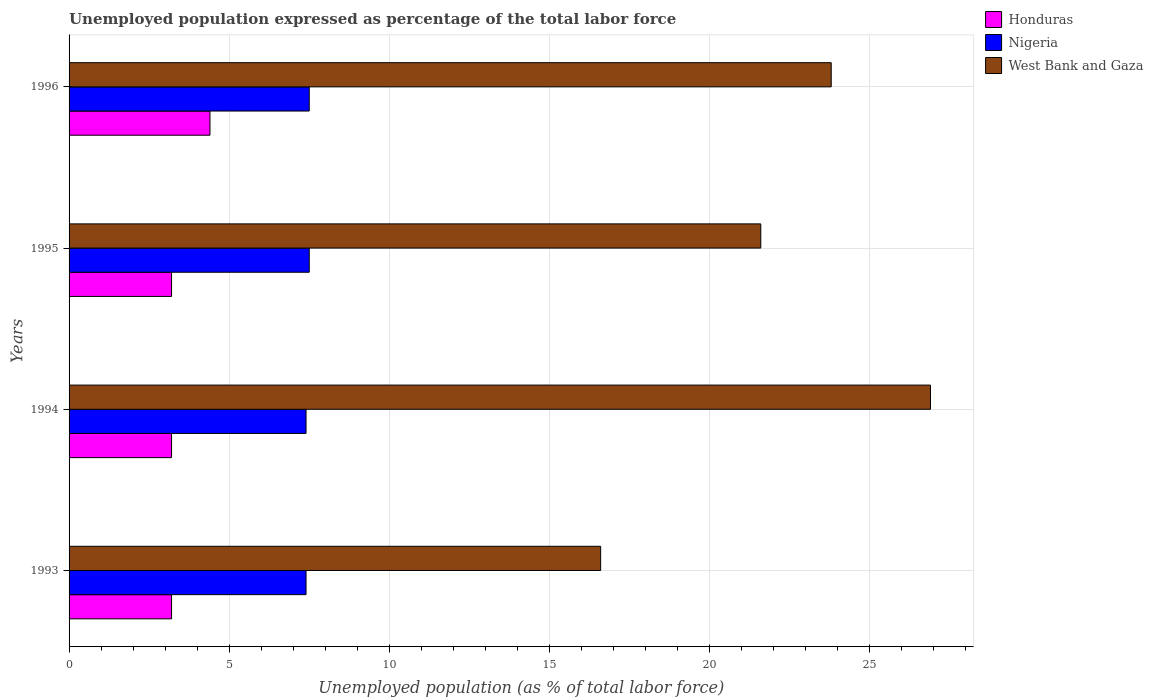How many different coloured bars are there?
Offer a terse response. 3. How many groups of bars are there?
Make the answer very short. 4. Are the number of bars per tick equal to the number of legend labels?
Ensure brevity in your answer.  Yes. Are the number of bars on each tick of the Y-axis equal?
Offer a very short reply. Yes. How many bars are there on the 2nd tick from the top?
Give a very brief answer. 3. In how many cases, is the number of bars for a given year not equal to the number of legend labels?
Your response must be concise. 0. What is the unemployment in in West Bank and Gaza in 1994?
Your answer should be very brief. 26.9. Across all years, what is the maximum unemployment in in West Bank and Gaza?
Keep it short and to the point. 26.9. Across all years, what is the minimum unemployment in in West Bank and Gaza?
Ensure brevity in your answer.  16.6. In which year was the unemployment in in Nigeria maximum?
Provide a succinct answer. 1995. What is the total unemployment in in Honduras in the graph?
Your response must be concise. 14. What is the difference between the unemployment in in Nigeria in 1995 and that in 1996?
Your answer should be very brief. 0. What is the difference between the unemployment in in Nigeria in 1993 and the unemployment in in West Bank and Gaza in 1994?
Your answer should be compact. -19.5. What is the average unemployment in in Nigeria per year?
Give a very brief answer. 7.45. In the year 1995, what is the difference between the unemployment in in Nigeria and unemployment in in West Bank and Gaza?
Provide a succinct answer. -14.1. What is the ratio of the unemployment in in Nigeria in 1994 to that in 1995?
Offer a very short reply. 0.99. Is the unemployment in in Honduras in 1994 less than that in 1996?
Offer a very short reply. Yes. What is the difference between the highest and the second highest unemployment in in Honduras?
Offer a terse response. 1.2. What is the difference between the highest and the lowest unemployment in in Honduras?
Your answer should be very brief. 1.2. Is the sum of the unemployment in in Nigeria in 1993 and 1994 greater than the maximum unemployment in in Honduras across all years?
Offer a terse response. Yes. What does the 2nd bar from the top in 1996 represents?
Your response must be concise. Nigeria. What does the 3rd bar from the bottom in 1994 represents?
Your response must be concise. West Bank and Gaza. Is it the case that in every year, the sum of the unemployment in in Nigeria and unemployment in in West Bank and Gaza is greater than the unemployment in in Honduras?
Give a very brief answer. Yes. How many bars are there?
Offer a very short reply. 12. Are all the bars in the graph horizontal?
Provide a short and direct response. Yes. Does the graph contain grids?
Your response must be concise. Yes. How many legend labels are there?
Provide a short and direct response. 3. What is the title of the graph?
Offer a terse response. Unemployed population expressed as percentage of the total labor force. Does "Belgium" appear as one of the legend labels in the graph?
Keep it short and to the point. No. What is the label or title of the X-axis?
Your answer should be very brief. Unemployed population (as % of total labor force). What is the label or title of the Y-axis?
Give a very brief answer. Years. What is the Unemployed population (as % of total labor force) of Honduras in 1993?
Provide a short and direct response. 3.2. What is the Unemployed population (as % of total labor force) of Nigeria in 1993?
Offer a terse response. 7.4. What is the Unemployed population (as % of total labor force) of West Bank and Gaza in 1993?
Your response must be concise. 16.6. What is the Unemployed population (as % of total labor force) of Honduras in 1994?
Keep it short and to the point. 3.2. What is the Unemployed population (as % of total labor force) of Nigeria in 1994?
Provide a succinct answer. 7.4. What is the Unemployed population (as % of total labor force) of West Bank and Gaza in 1994?
Ensure brevity in your answer.  26.9. What is the Unemployed population (as % of total labor force) of Honduras in 1995?
Give a very brief answer. 3.2. What is the Unemployed population (as % of total labor force) of West Bank and Gaza in 1995?
Make the answer very short. 21.6. What is the Unemployed population (as % of total labor force) of Honduras in 1996?
Keep it short and to the point. 4.4. What is the Unemployed population (as % of total labor force) of West Bank and Gaza in 1996?
Ensure brevity in your answer.  23.8. Across all years, what is the maximum Unemployed population (as % of total labor force) of Honduras?
Provide a succinct answer. 4.4. Across all years, what is the maximum Unemployed population (as % of total labor force) in Nigeria?
Your answer should be very brief. 7.5. Across all years, what is the maximum Unemployed population (as % of total labor force) of West Bank and Gaza?
Your answer should be very brief. 26.9. Across all years, what is the minimum Unemployed population (as % of total labor force) of Honduras?
Your answer should be very brief. 3.2. Across all years, what is the minimum Unemployed population (as % of total labor force) in Nigeria?
Provide a succinct answer. 7.4. Across all years, what is the minimum Unemployed population (as % of total labor force) in West Bank and Gaza?
Offer a very short reply. 16.6. What is the total Unemployed population (as % of total labor force) of Nigeria in the graph?
Give a very brief answer. 29.8. What is the total Unemployed population (as % of total labor force) in West Bank and Gaza in the graph?
Keep it short and to the point. 88.9. What is the difference between the Unemployed population (as % of total labor force) in Nigeria in 1993 and that in 1995?
Keep it short and to the point. -0.1. What is the difference between the Unemployed population (as % of total labor force) of Nigeria in 1993 and that in 1996?
Your answer should be very brief. -0.1. What is the difference between the Unemployed population (as % of total labor force) in West Bank and Gaza in 1993 and that in 1996?
Ensure brevity in your answer.  -7.2. What is the difference between the Unemployed population (as % of total labor force) of Honduras in 1994 and that in 1995?
Provide a short and direct response. 0. What is the difference between the Unemployed population (as % of total labor force) of Nigeria in 1994 and that in 1995?
Offer a very short reply. -0.1. What is the difference between the Unemployed population (as % of total labor force) of Honduras in 1994 and that in 1996?
Keep it short and to the point. -1.2. What is the difference between the Unemployed population (as % of total labor force) of West Bank and Gaza in 1994 and that in 1996?
Offer a very short reply. 3.1. What is the difference between the Unemployed population (as % of total labor force) in Honduras in 1995 and that in 1996?
Provide a short and direct response. -1.2. What is the difference between the Unemployed population (as % of total labor force) in Honduras in 1993 and the Unemployed population (as % of total labor force) in West Bank and Gaza in 1994?
Provide a short and direct response. -23.7. What is the difference between the Unemployed population (as % of total labor force) of Nigeria in 1993 and the Unemployed population (as % of total labor force) of West Bank and Gaza in 1994?
Your response must be concise. -19.5. What is the difference between the Unemployed population (as % of total labor force) of Honduras in 1993 and the Unemployed population (as % of total labor force) of Nigeria in 1995?
Offer a very short reply. -4.3. What is the difference between the Unemployed population (as % of total labor force) of Honduras in 1993 and the Unemployed population (as % of total labor force) of West Bank and Gaza in 1995?
Offer a very short reply. -18.4. What is the difference between the Unemployed population (as % of total labor force) of Nigeria in 1993 and the Unemployed population (as % of total labor force) of West Bank and Gaza in 1995?
Offer a terse response. -14.2. What is the difference between the Unemployed population (as % of total labor force) in Honduras in 1993 and the Unemployed population (as % of total labor force) in West Bank and Gaza in 1996?
Offer a terse response. -20.6. What is the difference between the Unemployed population (as % of total labor force) of Nigeria in 1993 and the Unemployed population (as % of total labor force) of West Bank and Gaza in 1996?
Keep it short and to the point. -16.4. What is the difference between the Unemployed population (as % of total labor force) of Honduras in 1994 and the Unemployed population (as % of total labor force) of Nigeria in 1995?
Ensure brevity in your answer.  -4.3. What is the difference between the Unemployed population (as % of total labor force) in Honduras in 1994 and the Unemployed population (as % of total labor force) in West Bank and Gaza in 1995?
Keep it short and to the point. -18.4. What is the difference between the Unemployed population (as % of total labor force) of Nigeria in 1994 and the Unemployed population (as % of total labor force) of West Bank and Gaza in 1995?
Ensure brevity in your answer.  -14.2. What is the difference between the Unemployed population (as % of total labor force) in Honduras in 1994 and the Unemployed population (as % of total labor force) in Nigeria in 1996?
Offer a very short reply. -4.3. What is the difference between the Unemployed population (as % of total labor force) of Honduras in 1994 and the Unemployed population (as % of total labor force) of West Bank and Gaza in 1996?
Offer a very short reply. -20.6. What is the difference between the Unemployed population (as % of total labor force) of Nigeria in 1994 and the Unemployed population (as % of total labor force) of West Bank and Gaza in 1996?
Offer a terse response. -16.4. What is the difference between the Unemployed population (as % of total labor force) in Honduras in 1995 and the Unemployed population (as % of total labor force) in West Bank and Gaza in 1996?
Give a very brief answer. -20.6. What is the difference between the Unemployed population (as % of total labor force) in Nigeria in 1995 and the Unemployed population (as % of total labor force) in West Bank and Gaza in 1996?
Your response must be concise. -16.3. What is the average Unemployed population (as % of total labor force) of Nigeria per year?
Offer a very short reply. 7.45. What is the average Unemployed population (as % of total labor force) of West Bank and Gaza per year?
Ensure brevity in your answer.  22.23. In the year 1993, what is the difference between the Unemployed population (as % of total labor force) of Honduras and Unemployed population (as % of total labor force) of West Bank and Gaza?
Provide a short and direct response. -13.4. In the year 1994, what is the difference between the Unemployed population (as % of total labor force) in Honduras and Unemployed population (as % of total labor force) in Nigeria?
Make the answer very short. -4.2. In the year 1994, what is the difference between the Unemployed population (as % of total labor force) in Honduras and Unemployed population (as % of total labor force) in West Bank and Gaza?
Offer a terse response. -23.7. In the year 1994, what is the difference between the Unemployed population (as % of total labor force) of Nigeria and Unemployed population (as % of total labor force) of West Bank and Gaza?
Your answer should be compact. -19.5. In the year 1995, what is the difference between the Unemployed population (as % of total labor force) of Honduras and Unemployed population (as % of total labor force) of Nigeria?
Ensure brevity in your answer.  -4.3. In the year 1995, what is the difference between the Unemployed population (as % of total labor force) of Honduras and Unemployed population (as % of total labor force) of West Bank and Gaza?
Give a very brief answer. -18.4. In the year 1995, what is the difference between the Unemployed population (as % of total labor force) of Nigeria and Unemployed population (as % of total labor force) of West Bank and Gaza?
Your response must be concise. -14.1. In the year 1996, what is the difference between the Unemployed population (as % of total labor force) in Honduras and Unemployed population (as % of total labor force) in Nigeria?
Your answer should be compact. -3.1. In the year 1996, what is the difference between the Unemployed population (as % of total labor force) in Honduras and Unemployed population (as % of total labor force) in West Bank and Gaza?
Your response must be concise. -19.4. In the year 1996, what is the difference between the Unemployed population (as % of total labor force) of Nigeria and Unemployed population (as % of total labor force) of West Bank and Gaza?
Offer a very short reply. -16.3. What is the ratio of the Unemployed population (as % of total labor force) of Nigeria in 1993 to that in 1994?
Your answer should be compact. 1. What is the ratio of the Unemployed population (as % of total labor force) in West Bank and Gaza in 1993 to that in 1994?
Your answer should be very brief. 0.62. What is the ratio of the Unemployed population (as % of total labor force) of Nigeria in 1993 to that in 1995?
Give a very brief answer. 0.99. What is the ratio of the Unemployed population (as % of total labor force) in West Bank and Gaza in 1993 to that in 1995?
Give a very brief answer. 0.77. What is the ratio of the Unemployed population (as % of total labor force) in Honduras in 1993 to that in 1996?
Offer a terse response. 0.73. What is the ratio of the Unemployed population (as % of total labor force) in Nigeria in 1993 to that in 1996?
Offer a very short reply. 0.99. What is the ratio of the Unemployed population (as % of total labor force) in West Bank and Gaza in 1993 to that in 1996?
Give a very brief answer. 0.7. What is the ratio of the Unemployed population (as % of total labor force) of Honduras in 1994 to that in 1995?
Provide a short and direct response. 1. What is the ratio of the Unemployed population (as % of total labor force) in Nigeria in 1994 to that in 1995?
Make the answer very short. 0.99. What is the ratio of the Unemployed population (as % of total labor force) of West Bank and Gaza in 1994 to that in 1995?
Offer a terse response. 1.25. What is the ratio of the Unemployed population (as % of total labor force) in Honduras in 1994 to that in 1996?
Offer a terse response. 0.73. What is the ratio of the Unemployed population (as % of total labor force) of Nigeria in 1994 to that in 1996?
Give a very brief answer. 0.99. What is the ratio of the Unemployed population (as % of total labor force) in West Bank and Gaza in 1994 to that in 1996?
Provide a short and direct response. 1.13. What is the ratio of the Unemployed population (as % of total labor force) in Honduras in 1995 to that in 1996?
Make the answer very short. 0.73. What is the ratio of the Unemployed population (as % of total labor force) of Nigeria in 1995 to that in 1996?
Ensure brevity in your answer.  1. What is the ratio of the Unemployed population (as % of total labor force) of West Bank and Gaza in 1995 to that in 1996?
Provide a succinct answer. 0.91. What is the difference between the highest and the second highest Unemployed population (as % of total labor force) in Honduras?
Offer a very short reply. 1.2. What is the difference between the highest and the second highest Unemployed population (as % of total labor force) of Nigeria?
Provide a succinct answer. 0. What is the difference between the highest and the second highest Unemployed population (as % of total labor force) in West Bank and Gaza?
Provide a succinct answer. 3.1. What is the difference between the highest and the lowest Unemployed population (as % of total labor force) in Honduras?
Give a very brief answer. 1.2. What is the difference between the highest and the lowest Unemployed population (as % of total labor force) of West Bank and Gaza?
Offer a terse response. 10.3. 